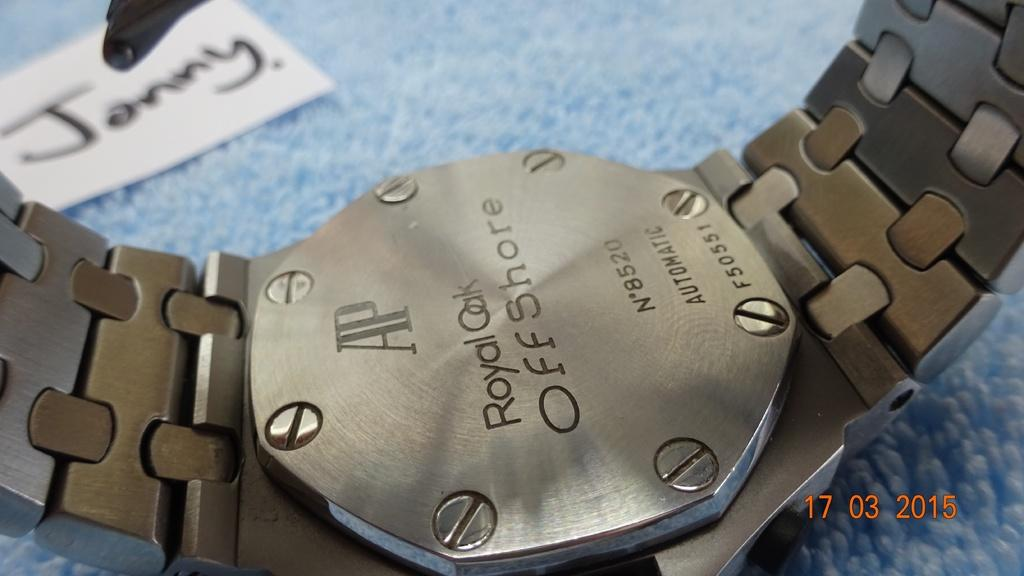Provide a one-sentence caption for the provided image. A watch is engraved with the text Royal Oak Offshore. 